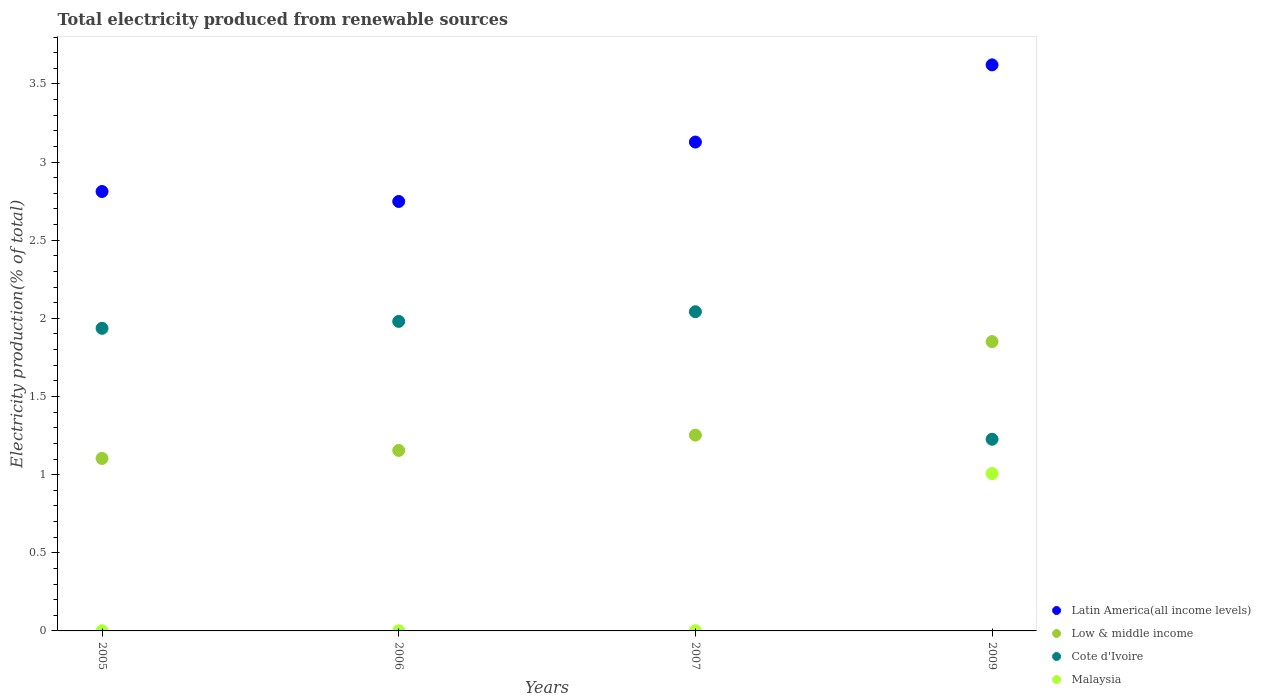What is the total electricity produced in Latin America(all income levels) in 2005?
Provide a succinct answer. 2.81. Across all years, what is the maximum total electricity produced in Cote d'Ivoire?
Provide a short and direct response. 2.04. Across all years, what is the minimum total electricity produced in Latin America(all income levels)?
Your answer should be compact. 2.75. In which year was the total electricity produced in Latin America(all income levels) maximum?
Your answer should be compact. 2009. What is the total total electricity produced in Low & middle income in the graph?
Give a very brief answer. 5.36. What is the difference between the total electricity produced in Low & middle income in 2006 and that in 2007?
Your answer should be very brief. -0.1. What is the difference between the total electricity produced in Latin America(all income levels) in 2006 and the total electricity produced in Cote d'Ivoire in 2009?
Give a very brief answer. 1.52. What is the average total electricity produced in Cote d'Ivoire per year?
Offer a very short reply. 1.8. In the year 2006, what is the difference between the total electricity produced in Latin America(all income levels) and total electricity produced in Malaysia?
Make the answer very short. 2.75. In how many years, is the total electricity produced in Malaysia greater than 0.6 %?
Make the answer very short. 1. What is the ratio of the total electricity produced in Low & middle income in 2006 to that in 2009?
Give a very brief answer. 0.62. Is the total electricity produced in Low & middle income in 2006 less than that in 2007?
Ensure brevity in your answer.  Yes. Is the difference between the total electricity produced in Latin America(all income levels) in 2005 and 2006 greater than the difference between the total electricity produced in Malaysia in 2005 and 2006?
Offer a very short reply. Yes. What is the difference between the highest and the second highest total electricity produced in Cote d'Ivoire?
Offer a terse response. 0.06. What is the difference between the highest and the lowest total electricity produced in Low & middle income?
Keep it short and to the point. 0.75. In how many years, is the total electricity produced in Malaysia greater than the average total electricity produced in Malaysia taken over all years?
Provide a succinct answer. 1. Is it the case that in every year, the sum of the total electricity produced in Latin America(all income levels) and total electricity produced in Cote d'Ivoire  is greater than the total electricity produced in Malaysia?
Offer a very short reply. Yes. Does the total electricity produced in Low & middle income monotonically increase over the years?
Ensure brevity in your answer.  Yes. Is the total electricity produced in Latin America(all income levels) strictly greater than the total electricity produced in Low & middle income over the years?
Ensure brevity in your answer.  Yes. Is the total electricity produced in Low & middle income strictly less than the total electricity produced in Malaysia over the years?
Keep it short and to the point. No. How many dotlines are there?
Make the answer very short. 4. What is the difference between two consecutive major ticks on the Y-axis?
Your answer should be compact. 0.5. Does the graph contain any zero values?
Your response must be concise. No. Does the graph contain grids?
Your answer should be compact. No. How many legend labels are there?
Offer a very short reply. 4. What is the title of the graph?
Offer a terse response. Total electricity produced from renewable sources. Does "Kazakhstan" appear as one of the legend labels in the graph?
Give a very brief answer. No. What is the label or title of the Y-axis?
Make the answer very short. Electricity production(% of total). What is the Electricity production(% of total) of Latin America(all income levels) in 2005?
Make the answer very short. 2.81. What is the Electricity production(% of total) of Low & middle income in 2005?
Offer a very short reply. 1.1. What is the Electricity production(% of total) of Cote d'Ivoire in 2005?
Keep it short and to the point. 1.94. What is the Electricity production(% of total) of Malaysia in 2005?
Offer a terse response. 0. What is the Electricity production(% of total) of Latin America(all income levels) in 2006?
Keep it short and to the point. 2.75. What is the Electricity production(% of total) of Low & middle income in 2006?
Give a very brief answer. 1.16. What is the Electricity production(% of total) of Cote d'Ivoire in 2006?
Make the answer very short. 1.98. What is the Electricity production(% of total) of Malaysia in 2006?
Give a very brief answer. 0. What is the Electricity production(% of total) of Latin America(all income levels) in 2007?
Your response must be concise. 3.13. What is the Electricity production(% of total) in Low & middle income in 2007?
Provide a short and direct response. 1.25. What is the Electricity production(% of total) in Cote d'Ivoire in 2007?
Offer a very short reply. 2.04. What is the Electricity production(% of total) of Malaysia in 2007?
Provide a succinct answer. 0. What is the Electricity production(% of total) of Latin America(all income levels) in 2009?
Your answer should be very brief. 3.62. What is the Electricity production(% of total) in Low & middle income in 2009?
Provide a succinct answer. 1.85. What is the Electricity production(% of total) of Cote d'Ivoire in 2009?
Give a very brief answer. 1.23. What is the Electricity production(% of total) in Malaysia in 2009?
Offer a very short reply. 1.01. Across all years, what is the maximum Electricity production(% of total) of Latin America(all income levels)?
Make the answer very short. 3.62. Across all years, what is the maximum Electricity production(% of total) in Low & middle income?
Your response must be concise. 1.85. Across all years, what is the maximum Electricity production(% of total) of Cote d'Ivoire?
Offer a very short reply. 2.04. Across all years, what is the maximum Electricity production(% of total) in Malaysia?
Make the answer very short. 1.01. Across all years, what is the minimum Electricity production(% of total) in Latin America(all income levels)?
Make the answer very short. 2.75. Across all years, what is the minimum Electricity production(% of total) in Low & middle income?
Offer a very short reply. 1.1. Across all years, what is the minimum Electricity production(% of total) of Cote d'Ivoire?
Your answer should be compact. 1.23. Across all years, what is the minimum Electricity production(% of total) of Malaysia?
Make the answer very short. 0. What is the total Electricity production(% of total) of Latin America(all income levels) in the graph?
Your answer should be very brief. 12.31. What is the total Electricity production(% of total) in Low & middle income in the graph?
Offer a terse response. 5.36. What is the total Electricity production(% of total) in Cote d'Ivoire in the graph?
Give a very brief answer. 7.19. What is the total Electricity production(% of total) in Malaysia in the graph?
Provide a short and direct response. 1.01. What is the difference between the Electricity production(% of total) in Latin America(all income levels) in 2005 and that in 2006?
Offer a terse response. 0.06. What is the difference between the Electricity production(% of total) in Low & middle income in 2005 and that in 2006?
Offer a terse response. -0.05. What is the difference between the Electricity production(% of total) in Cote d'Ivoire in 2005 and that in 2006?
Offer a terse response. -0.04. What is the difference between the Electricity production(% of total) in Latin America(all income levels) in 2005 and that in 2007?
Offer a terse response. -0.32. What is the difference between the Electricity production(% of total) of Low & middle income in 2005 and that in 2007?
Make the answer very short. -0.15. What is the difference between the Electricity production(% of total) of Cote d'Ivoire in 2005 and that in 2007?
Provide a succinct answer. -0.11. What is the difference between the Electricity production(% of total) in Latin America(all income levels) in 2005 and that in 2009?
Offer a very short reply. -0.81. What is the difference between the Electricity production(% of total) in Low & middle income in 2005 and that in 2009?
Your response must be concise. -0.75. What is the difference between the Electricity production(% of total) in Cote d'Ivoire in 2005 and that in 2009?
Give a very brief answer. 0.71. What is the difference between the Electricity production(% of total) of Malaysia in 2005 and that in 2009?
Your answer should be very brief. -1.01. What is the difference between the Electricity production(% of total) of Latin America(all income levels) in 2006 and that in 2007?
Your answer should be very brief. -0.38. What is the difference between the Electricity production(% of total) in Low & middle income in 2006 and that in 2007?
Offer a very short reply. -0.1. What is the difference between the Electricity production(% of total) in Cote d'Ivoire in 2006 and that in 2007?
Provide a succinct answer. -0.06. What is the difference between the Electricity production(% of total) in Latin America(all income levels) in 2006 and that in 2009?
Your answer should be compact. -0.87. What is the difference between the Electricity production(% of total) of Low & middle income in 2006 and that in 2009?
Give a very brief answer. -0.7. What is the difference between the Electricity production(% of total) of Cote d'Ivoire in 2006 and that in 2009?
Provide a succinct answer. 0.75. What is the difference between the Electricity production(% of total) of Malaysia in 2006 and that in 2009?
Give a very brief answer. -1.01. What is the difference between the Electricity production(% of total) in Latin America(all income levels) in 2007 and that in 2009?
Offer a very short reply. -0.49. What is the difference between the Electricity production(% of total) in Low & middle income in 2007 and that in 2009?
Offer a very short reply. -0.6. What is the difference between the Electricity production(% of total) in Cote d'Ivoire in 2007 and that in 2009?
Provide a short and direct response. 0.82. What is the difference between the Electricity production(% of total) of Malaysia in 2007 and that in 2009?
Keep it short and to the point. -1.01. What is the difference between the Electricity production(% of total) in Latin America(all income levels) in 2005 and the Electricity production(% of total) in Low & middle income in 2006?
Give a very brief answer. 1.66. What is the difference between the Electricity production(% of total) of Latin America(all income levels) in 2005 and the Electricity production(% of total) of Cote d'Ivoire in 2006?
Provide a short and direct response. 0.83. What is the difference between the Electricity production(% of total) of Latin America(all income levels) in 2005 and the Electricity production(% of total) of Malaysia in 2006?
Make the answer very short. 2.81. What is the difference between the Electricity production(% of total) of Low & middle income in 2005 and the Electricity production(% of total) of Cote d'Ivoire in 2006?
Provide a succinct answer. -0.88. What is the difference between the Electricity production(% of total) of Low & middle income in 2005 and the Electricity production(% of total) of Malaysia in 2006?
Provide a succinct answer. 1.1. What is the difference between the Electricity production(% of total) of Cote d'Ivoire in 2005 and the Electricity production(% of total) of Malaysia in 2006?
Provide a short and direct response. 1.94. What is the difference between the Electricity production(% of total) in Latin America(all income levels) in 2005 and the Electricity production(% of total) in Low & middle income in 2007?
Keep it short and to the point. 1.56. What is the difference between the Electricity production(% of total) of Latin America(all income levels) in 2005 and the Electricity production(% of total) of Cote d'Ivoire in 2007?
Offer a terse response. 0.77. What is the difference between the Electricity production(% of total) in Latin America(all income levels) in 2005 and the Electricity production(% of total) in Malaysia in 2007?
Offer a terse response. 2.81. What is the difference between the Electricity production(% of total) of Low & middle income in 2005 and the Electricity production(% of total) of Cote d'Ivoire in 2007?
Provide a short and direct response. -0.94. What is the difference between the Electricity production(% of total) in Low & middle income in 2005 and the Electricity production(% of total) in Malaysia in 2007?
Your answer should be compact. 1.1. What is the difference between the Electricity production(% of total) of Cote d'Ivoire in 2005 and the Electricity production(% of total) of Malaysia in 2007?
Your response must be concise. 1.94. What is the difference between the Electricity production(% of total) in Latin America(all income levels) in 2005 and the Electricity production(% of total) in Low & middle income in 2009?
Offer a terse response. 0.96. What is the difference between the Electricity production(% of total) of Latin America(all income levels) in 2005 and the Electricity production(% of total) of Cote d'Ivoire in 2009?
Offer a terse response. 1.59. What is the difference between the Electricity production(% of total) in Latin America(all income levels) in 2005 and the Electricity production(% of total) in Malaysia in 2009?
Ensure brevity in your answer.  1.8. What is the difference between the Electricity production(% of total) in Low & middle income in 2005 and the Electricity production(% of total) in Cote d'Ivoire in 2009?
Your answer should be very brief. -0.12. What is the difference between the Electricity production(% of total) of Low & middle income in 2005 and the Electricity production(% of total) of Malaysia in 2009?
Keep it short and to the point. 0.1. What is the difference between the Electricity production(% of total) of Cote d'Ivoire in 2005 and the Electricity production(% of total) of Malaysia in 2009?
Offer a terse response. 0.93. What is the difference between the Electricity production(% of total) in Latin America(all income levels) in 2006 and the Electricity production(% of total) in Low & middle income in 2007?
Keep it short and to the point. 1.49. What is the difference between the Electricity production(% of total) in Latin America(all income levels) in 2006 and the Electricity production(% of total) in Cote d'Ivoire in 2007?
Offer a terse response. 0.71. What is the difference between the Electricity production(% of total) of Latin America(all income levels) in 2006 and the Electricity production(% of total) of Malaysia in 2007?
Keep it short and to the point. 2.75. What is the difference between the Electricity production(% of total) of Low & middle income in 2006 and the Electricity production(% of total) of Cote d'Ivoire in 2007?
Offer a very short reply. -0.89. What is the difference between the Electricity production(% of total) of Low & middle income in 2006 and the Electricity production(% of total) of Malaysia in 2007?
Make the answer very short. 1.15. What is the difference between the Electricity production(% of total) in Cote d'Ivoire in 2006 and the Electricity production(% of total) in Malaysia in 2007?
Keep it short and to the point. 1.98. What is the difference between the Electricity production(% of total) of Latin America(all income levels) in 2006 and the Electricity production(% of total) of Low & middle income in 2009?
Ensure brevity in your answer.  0.9. What is the difference between the Electricity production(% of total) in Latin America(all income levels) in 2006 and the Electricity production(% of total) in Cote d'Ivoire in 2009?
Provide a succinct answer. 1.52. What is the difference between the Electricity production(% of total) of Latin America(all income levels) in 2006 and the Electricity production(% of total) of Malaysia in 2009?
Your answer should be compact. 1.74. What is the difference between the Electricity production(% of total) of Low & middle income in 2006 and the Electricity production(% of total) of Cote d'Ivoire in 2009?
Provide a succinct answer. -0.07. What is the difference between the Electricity production(% of total) of Low & middle income in 2006 and the Electricity production(% of total) of Malaysia in 2009?
Offer a very short reply. 0.15. What is the difference between the Electricity production(% of total) of Cote d'Ivoire in 2006 and the Electricity production(% of total) of Malaysia in 2009?
Provide a succinct answer. 0.97. What is the difference between the Electricity production(% of total) of Latin America(all income levels) in 2007 and the Electricity production(% of total) of Low & middle income in 2009?
Keep it short and to the point. 1.28. What is the difference between the Electricity production(% of total) of Latin America(all income levels) in 2007 and the Electricity production(% of total) of Cote d'Ivoire in 2009?
Provide a short and direct response. 1.9. What is the difference between the Electricity production(% of total) in Latin America(all income levels) in 2007 and the Electricity production(% of total) in Malaysia in 2009?
Offer a very short reply. 2.12. What is the difference between the Electricity production(% of total) in Low & middle income in 2007 and the Electricity production(% of total) in Cote d'Ivoire in 2009?
Provide a succinct answer. 0.03. What is the difference between the Electricity production(% of total) of Low & middle income in 2007 and the Electricity production(% of total) of Malaysia in 2009?
Your answer should be compact. 0.25. What is the difference between the Electricity production(% of total) of Cote d'Ivoire in 2007 and the Electricity production(% of total) of Malaysia in 2009?
Your answer should be compact. 1.04. What is the average Electricity production(% of total) of Latin America(all income levels) per year?
Provide a short and direct response. 3.08. What is the average Electricity production(% of total) in Low & middle income per year?
Offer a terse response. 1.34. What is the average Electricity production(% of total) in Cote d'Ivoire per year?
Offer a very short reply. 1.8. What is the average Electricity production(% of total) in Malaysia per year?
Your response must be concise. 0.25. In the year 2005, what is the difference between the Electricity production(% of total) in Latin America(all income levels) and Electricity production(% of total) in Low & middle income?
Provide a short and direct response. 1.71. In the year 2005, what is the difference between the Electricity production(% of total) in Latin America(all income levels) and Electricity production(% of total) in Cote d'Ivoire?
Your response must be concise. 0.88. In the year 2005, what is the difference between the Electricity production(% of total) in Latin America(all income levels) and Electricity production(% of total) in Malaysia?
Make the answer very short. 2.81. In the year 2005, what is the difference between the Electricity production(% of total) of Low & middle income and Electricity production(% of total) of Cote d'Ivoire?
Offer a terse response. -0.83. In the year 2005, what is the difference between the Electricity production(% of total) in Low & middle income and Electricity production(% of total) in Malaysia?
Offer a very short reply. 1.1. In the year 2005, what is the difference between the Electricity production(% of total) of Cote d'Ivoire and Electricity production(% of total) of Malaysia?
Provide a succinct answer. 1.94. In the year 2006, what is the difference between the Electricity production(% of total) in Latin America(all income levels) and Electricity production(% of total) in Low & middle income?
Ensure brevity in your answer.  1.59. In the year 2006, what is the difference between the Electricity production(% of total) of Latin America(all income levels) and Electricity production(% of total) of Cote d'Ivoire?
Your response must be concise. 0.77. In the year 2006, what is the difference between the Electricity production(% of total) in Latin America(all income levels) and Electricity production(% of total) in Malaysia?
Make the answer very short. 2.75. In the year 2006, what is the difference between the Electricity production(% of total) in Low & middle income and Electricity production(% of total) in Cote d'Ivoire?
Offer a terse response. -0.83. In the year 2006, what is the difference between the Electricity production(% of total) of Low & middle income and Electricity production(% of total) of Malaysia?
Offer a terse response. 1.15. In the year 2006, what is the difference between the Electricity production(% of total) of Cote d'Ivoire and Electricity production(% of total) of Malaysia?
Offer a very short reply. 1.98. In the year 2007, what is the difference between the Electricity production(% of total) in Latin America(all income levels) and Electricity production(% of total) in Low & middle income?
Make the answer very short. 1.88. In the year 2007, what is the difference between the Electricity production(% of total) in Latin America(all income levels) and Electricity production(% of total) in Cote d'Ivoire?
Ensure brevity in your answer.  1.09. In the year 2007, what is the difference between the Electricity production(% of total) in Latin America(all income levels) and Electricity production(% of total) in Malaysia?
Keep it short and to the point. 3.13. In the year 2007, what is the difference between the Electricity production(% of total) in Low & middle income and Electricity production(% of total) in Cote d'Ivoire?
Make the answer very short. -0.79. In the year 2007, what is the difference between the Electricity production(% of total) of Low & middle income and Electricity production(% of total) of Malaysia?
Your answer should be compact. 1.25. In the year 2007, what is the difference between the Electricity production(% of total) in Cote d'Ivoire and Electricity production(% of total) in Malaysia?
Ensure brevity in your answer.  2.04. In the year 2009, what is the difference between the Electricity production(% of total) in Latin America(all income levels) and Electricity production(% of total) in Low & middle income?
Keep it short and to the point. 1.77. In the year 2009, what is the difference between the Electricity production(% of total) in Latin America(all income levels) and Electricity production(% of total) in Cote d'Ivoire?
Your response must be concise. 2.4. In the year 2009, what is the difference between the Electricity production(% of total) in Latin America(all income levels) and Electricity production(% of total) in Malaysia?
Give a very brief answer. 2.62. In the year 2009, what is the difference between the Electricity production(% of total) in Low & middle income and Electricity production(% of total) in Cote d'Ivoire?
Keep it short and to the point. 0.62. In the year 2009, what is the difference between the Electricity production(% of total) in Low & middle income and Electricity production(% of total) in Malaysia?
Offer a terse response. 0.84. In the year 2009, what is the difference between the Electricity production(% of total) in Cote d'Ivoire and Electricity production(% of total) in Malaysia?
Give a very brief answer. 0.22. What is the ratio of the Electricity production(% of total) in Latin America(all income levels) in 2005 to that in 2006?
Make the answer very short. 1.02. What is the ratio of the Electricity production(% of total) in Low & middle income in 2005 to that in 2006?
Your answer should be very brief. 0.96. What is the ratio of the Electricity production(% of total) of Cote d'Ivoire in 2005 to that in 2006?
Offer a very short reply. 0.98. What is the ratio of the Electricity production(% of total) of Malaysia in 2005 to that in 2006?
Your response must be concise. 1.09. What is the ratio of the Electricity production(% of total) in Latin America(all income levels) in 2005 to that in 2007?
Give a very brief answer. 0.9. What is the ratio of the Electricity production(% of total) of Low & middle income in 2005 to that in 2007?
Provide a short and direct response. 0.88. What is the ratio of the Electricity production(% of total) of Cote d'Ivoire in 2005 to that in 2007?
Ensure brevity in your answer.  0.95. What is the ratio of the Electricity production(% of total) in Malaysia in 2005 to that in 2007?
Offer a terse response. 1.18. What is the ratio of the Electricity production(% of total) in Latin America(all income levels) in 2005 to that in 2009?
Your answer should be very brief. 0.78. What is the ratio of the Electricity production(% of total) of Low & middle income in 2005 to that in 2009?
Your response must be concise. 0.6. What is the ratio of the Electricity production(% of total) in Cote d'Ivoire in 2005 to that in 2009?
Your response must be concise. 1.58. What is the ratio of the Electricity production(% of total) in Malaysia in 2005 to that in 2009?
Your answer should be very brief. 0. What is the ratio of the Electricity production(% of total) in Latin America(all income levels) in 2006 to that in 2007?
Provide a succinct answer. 0.88. What is the ratio of the Electricity production(% of total) in Low & middle income in 2006 to that in 2007?
Offer a terse response. 0.92. What is the ratio of the Electricity production(% of total) in Cote d'Ivoire in 2006 to that in 2007?
Provide a succinct answer. 0.97. What is the ratio of the Electricity production(% of total) in Malaysia in 2006 to that in 2007?
Provide a short and direct response. 1.09. What is the ratio of the Electricity production(% of total) in Latin America(all income levels) in 2006 to that in 2009?
Keep it short and to the point. 0.76. What is the ratio of the Electricity production(% of total) in Low & middle income in 2006 to that in 2009?
Make the answer very short. 0.62. What is the ratio of the Electricity production(% of total) of Cote d'Ivoire in 2006 to that in 2009?
Ensure brevity in your answer.  1.61. What is the ratio of the Electricity production(% of total) in Malaysia in 2006 to that in 2009?
Provide a succinct answer. 0. What is the ratio of the Electricity production(% of total) of Latin America(all income levels) in 2007 to that in 2009?
Your response must be concise. 0.86. What is the ratio of the Electricity production(% of total) in Low & middle income in 2007 to that in 2009?
Provide a short and direct response. 0.68. What is the ratio of the Electricity production(% of total) in Cote d'Ivoire in 2007 to that in 2009?
Your answer should be compact. 1.67. What is the ratio of the Electricity production(% of total) of Malaysia in 2007 to that in 2009?
Your answer should be compact. 0. What is the difference between the highest and the second highest Electricity production(% of total) of Latin America(all income levels)?
Provide a succinct answer. 0.49. What is the difference between the highest and the second highest Electricity production(% of total) of Low & middle income?
Make the answer very short. 0.6. What is the difference between the highest and the second highest Electricity production(% of total) of Cote d'Ivoire?
Your answer should be very brief. 0.06. What is the difference between the highest and the second highest Electricity production(% of total) of Malaysia?
Provide a succinct answer. 1.01. What is the difference between the highest and the lowest Electricity production(% of total) of Latin America(all income levels)?
Offer a very short reply. 0.87. What is the difference between the highest and the lowest Electricity production(% of total) of Low & middle income?
Your answer should be very brief. 0.75. What is the difference between the highest and the lowest Electricity production(% of total) in Cote d'Ivoire?
Offer a terse response. 0.82. What is the difference between the highest and the lowest Electricity production(% of total) of Malaysia?
Provide a short and direct response. 1.01. 